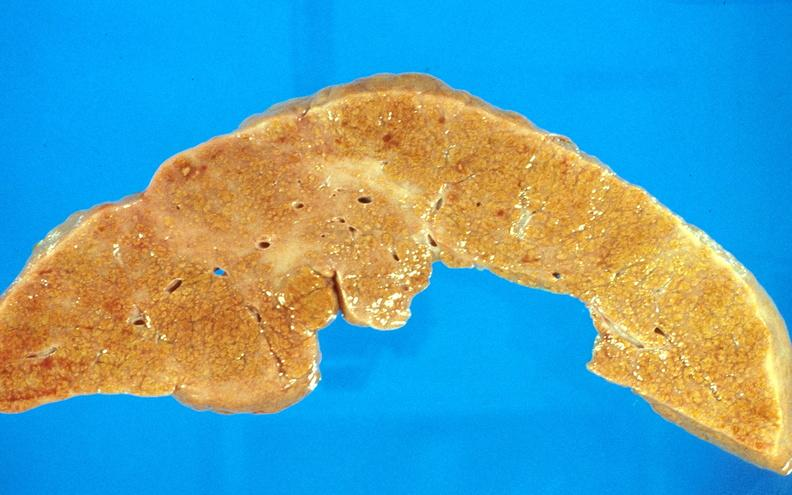does carcinoma superficial spreading show cirrhosis?
Answer the question using a single word or phrase. No 